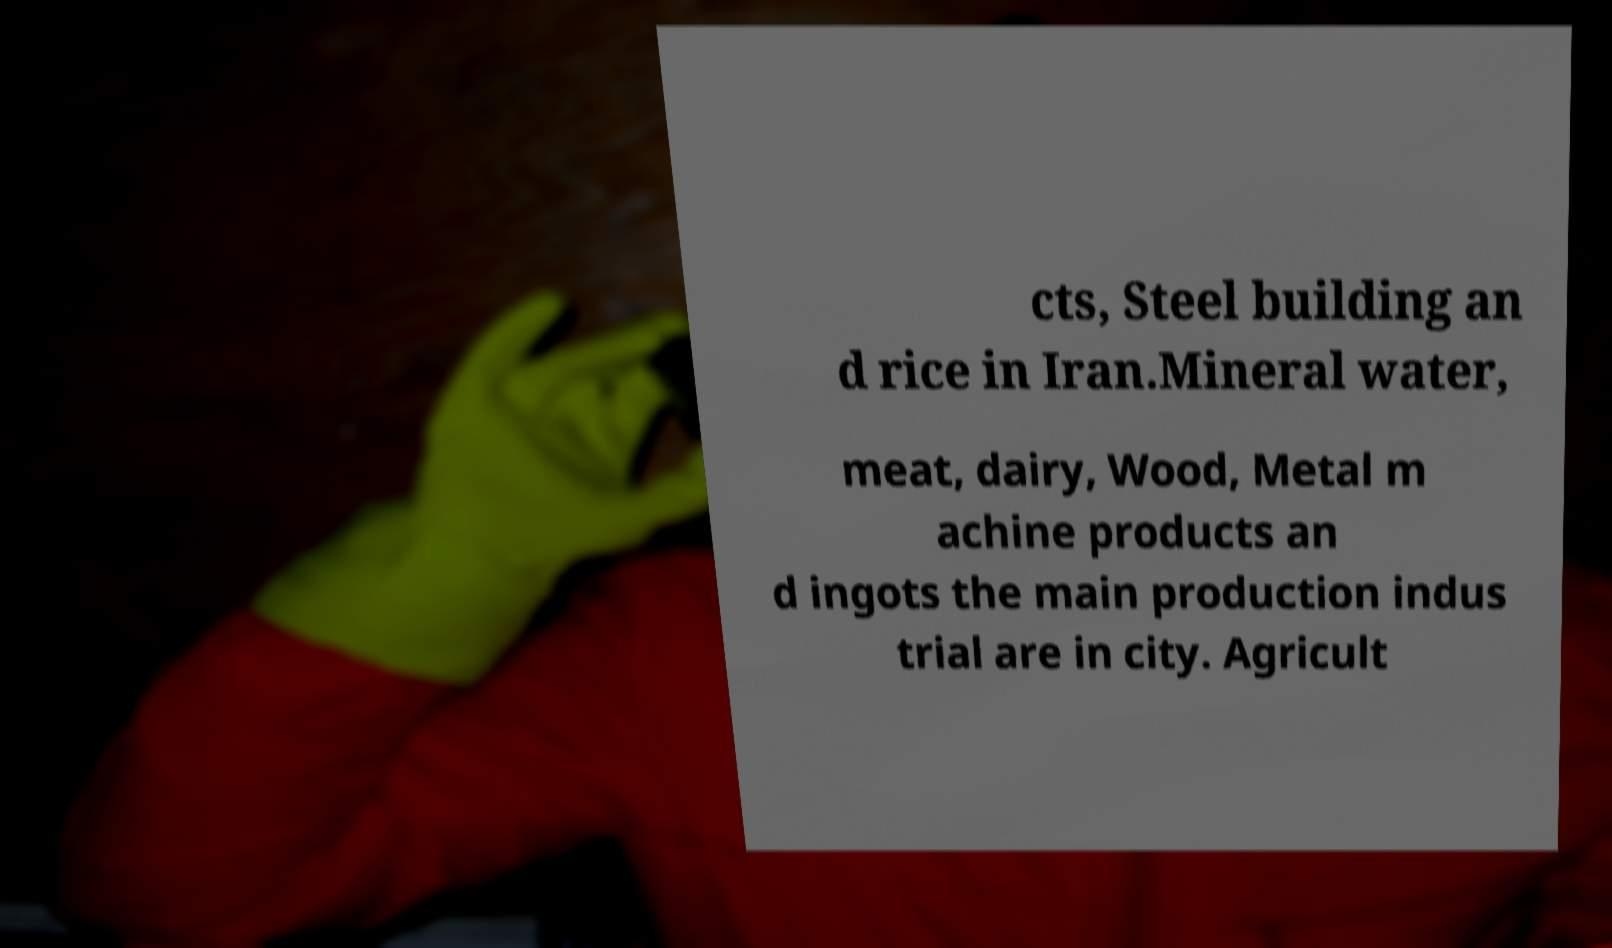What messages or text are displayed in this image? I need them in a readable, typed format. cts, Steel building an d rice in Iran.Mineral water, meat, dairy, Wood, Metal m achine products an d ingots the main production indus trial are in city. Agricult 